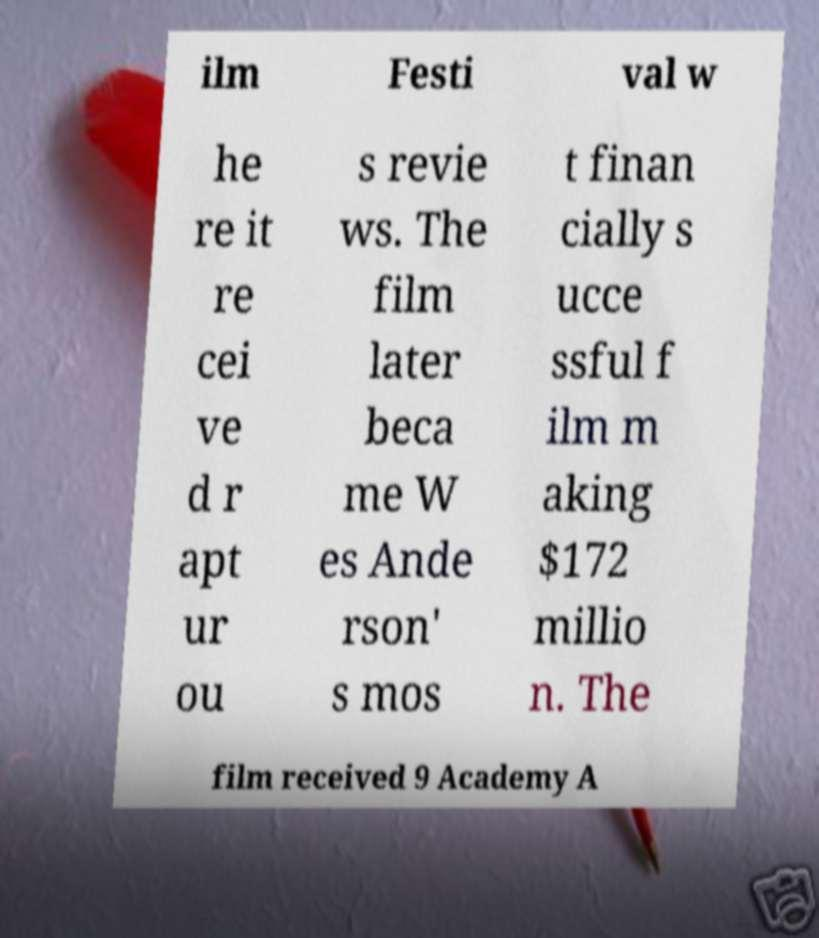Please read and relay the text visible in this image. What does it say? ilm Festi val w he re it re cei ve d r apt ur ou s revie ws. The film later beca me W es Ande rson' s mos t finan cially s ucce ssful f ilm m aking $172 millio n. The film received 9 Academy A 